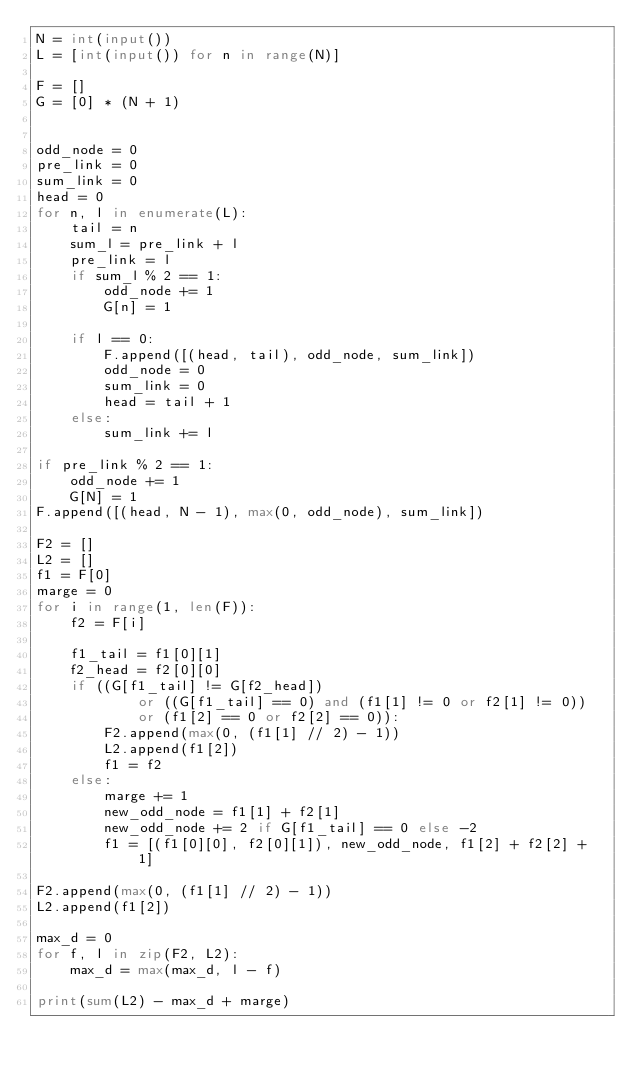<code> <loc_0><loc_0><loc_500><loc_500><_Python_>N = int(input())
L = [int(input()) for n in range(N)]

F = []
G = [0] * (N + 1)


odd_node = 0
pre_link = 0
sum_link = 0
head = 0
for n, l in enumerate(L):
    tail = n
    sum_l = pre_link + l
    pre_link = l
    if sum_l % 2 == 1:
        odd_node += 1
        G[n] = 1

    if l == 0:
        F.append([(head, tail), odd_node, sum_link])
        odd_node = 0
        sum_link = 0
        head = tail + 1
    else:
        sum_link += l

if pre_link % 2 == 1:
    odd_node += 1
    G[N] = 1
F.append([(head, N - 1), max(0, odd_node), sum_link])

F2 = []
L2 = []
f1 = F[0]
marge = 0
for i in range(1, len(F)):
    f2 = F[i]

    f1_tail = f1[0][1]
    f2_head = f2[0][0]
    if ((G[f1_tail] != G[f2_head])
            or ((G[f1_tail] == 0) and (f1[1] != 0 or f2[1] != 0))
            or (f1[2] == 0 or f2[2] == 0)):
        F2.append(max(0, (f1[1] // 2) - 1))
        L2.append(f1[2])
        f1 = f2
    else:
        marge += 1
        new_odd_node = f1[1] + f2[1]
        new_odd_node += 2 if G[f1_tail] == 0 else -2
        f1 = [(f1[0][0], f2[0][1]), new_odd_node, f1[2] + f2[2] + 1]

F2.append(max(0, (f1[1] // 2) - 1))
L2.append(f1[2])

max_d = 0
for f, l in zip(F2, L2):
    max_d = max(max_d, l - f)

print(sum(L2) - max_d + marge)
</code> 